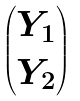Convert formula to latex. <formula><loc_0><loc_0><loc_500><loc_500>\begin{pmatrix} Y _ { 1 } \\ Y _ { 2 } \end{pmatrix}</formula> 